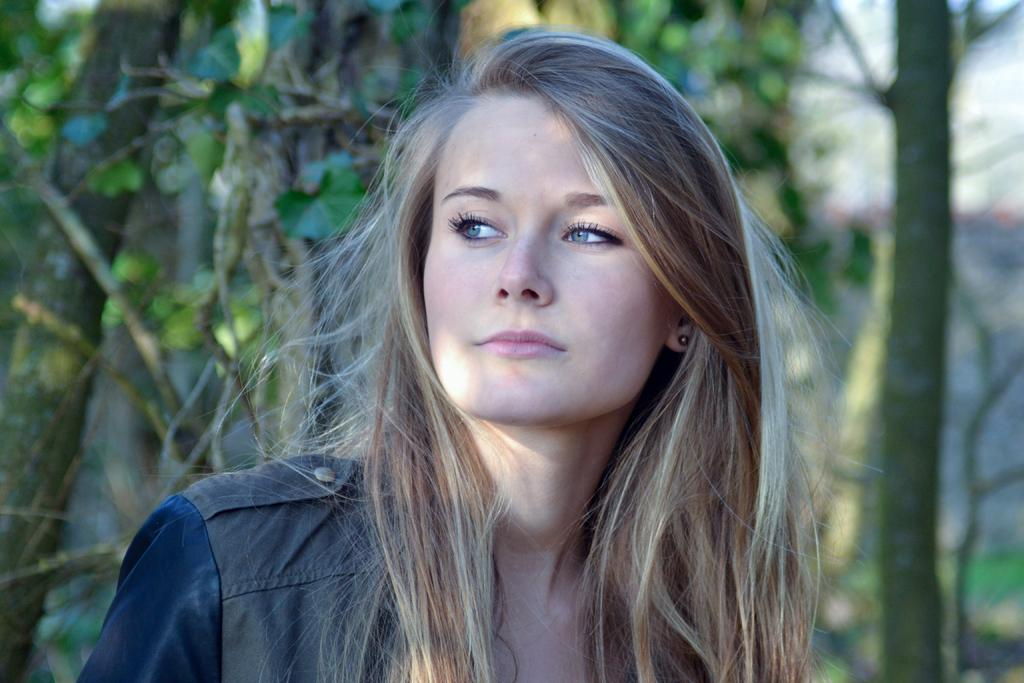Where was the image taken? The image was taken outdoors. What can be seen in the background of the image? There are trees with green leaves, stems, and branches in the background. Who is the main subject in the image? There is a girl in the middle of the image. What is the color of the girl's hair? The girl has brown hair. What does the caption say about the girl's actions in the image? There is no caption present in the image, so it is not possible to determine what the girl's actions are based on a caption. 